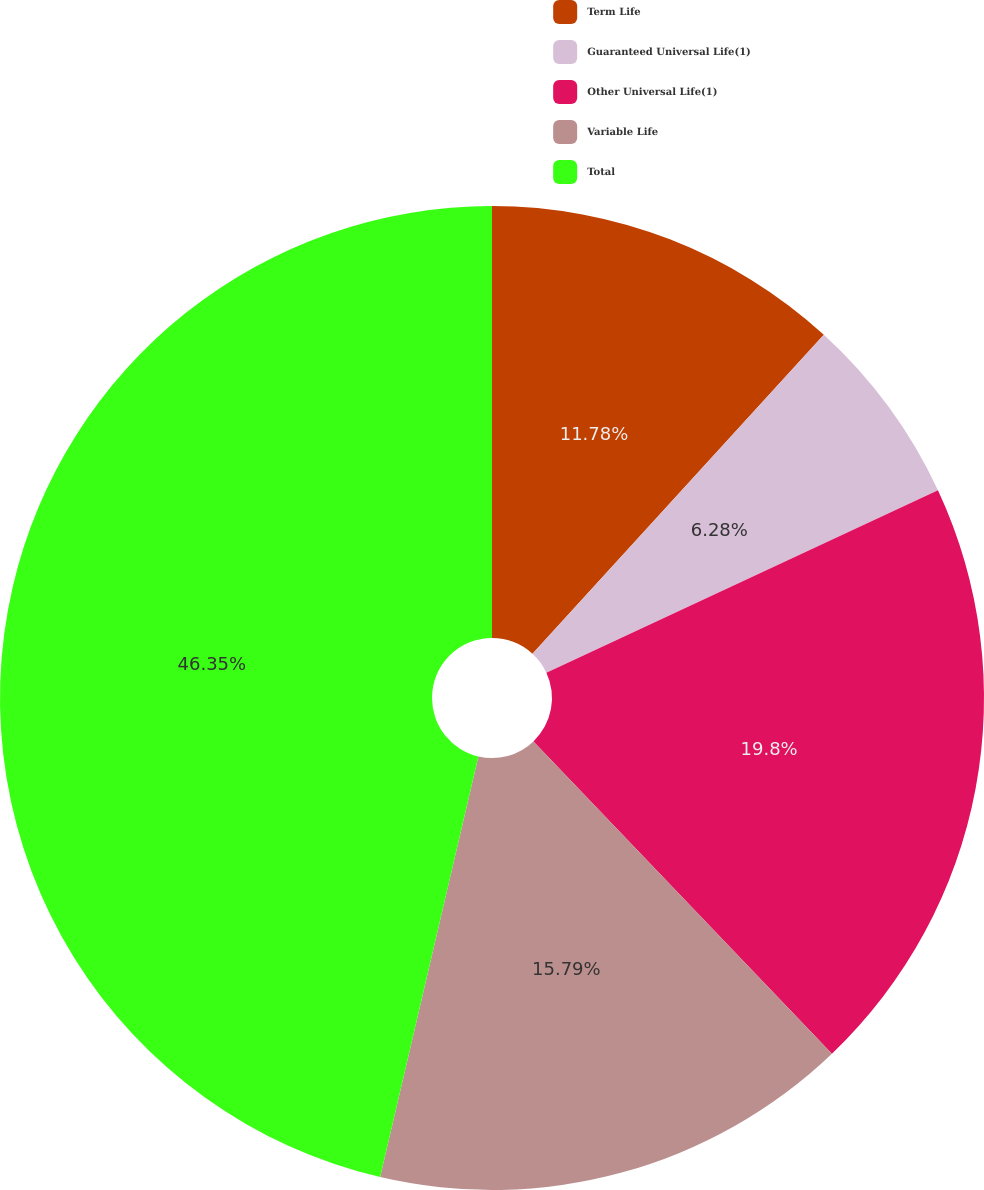<chart> <loc_0><loc_0><loc_500><loc_500><pie_chart><fcel>Term Life<fcel>Guaranteed Universal Life(1)<fcel>Other Universal Life(1)<fcel>Variable Life<fcel>Total<nl><fcel>11.78%<fcel>6.28%<fcel>19.8%<fcel>15.79%<fcel>46.35%<nl></chart> 